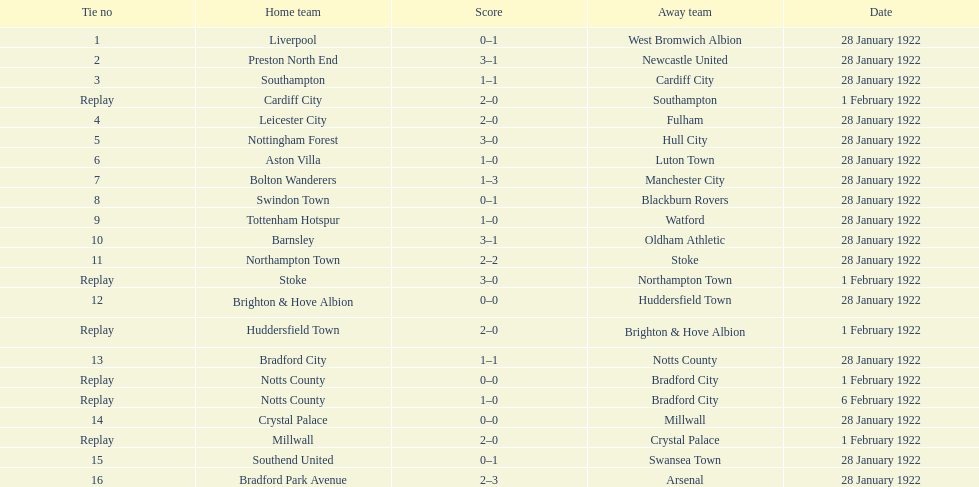Which game had a higher total number of goals scored, 1 or 16? 16. 